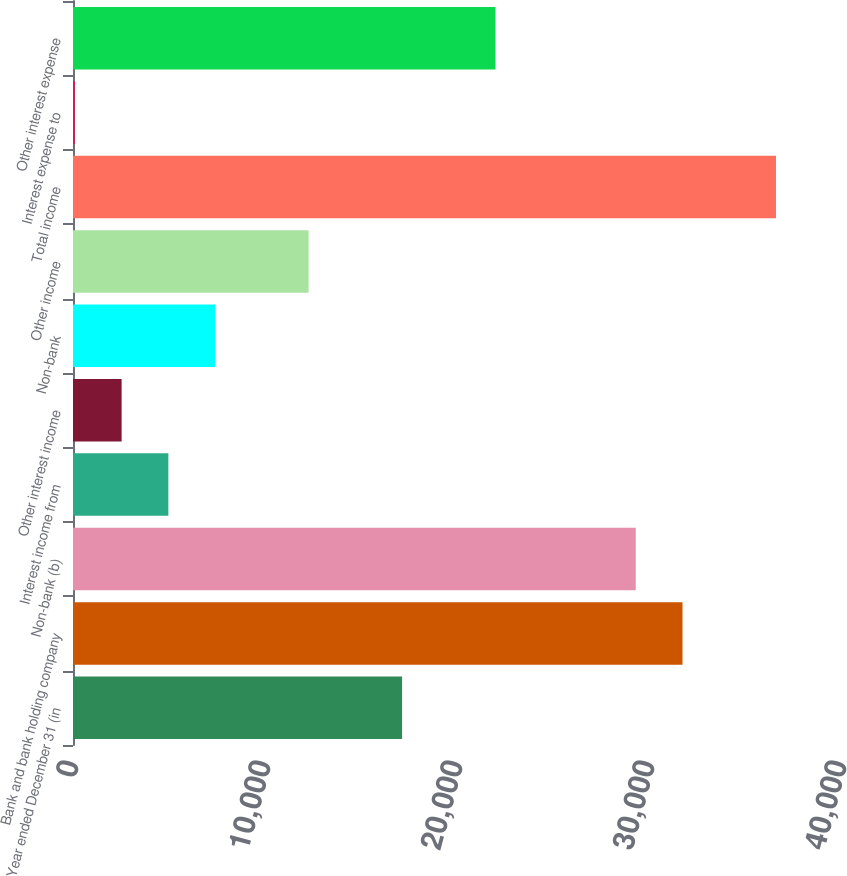<chart> <loc_0><loc_0><loc_500><loc_500><bar_chart><fcel>Year ended December 31 (in<fcel>Bank and bank holding company<fcel>Non-bank (b)<fcel>Interest income from<fcel>Other interest income<fcel>Non-bank<fcel>Other income<fcel>Total income<fcel>Interest expense to<fcel>Other interest expense<nl><fcel>17138.8<fcel>31745.2<fcel>29310.8<fcel>4966.8<fcel>2532.4<fcel>7401.2<fcel>12270<fcel>36614<fcel>98<fcel>22007.6<nl></chart> 